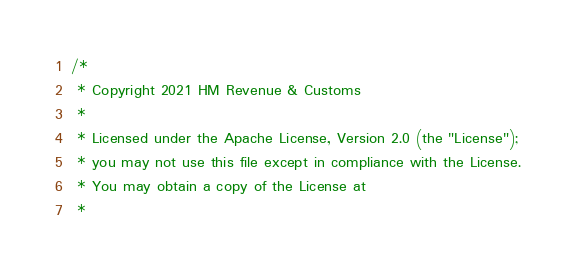Convert code to text. <code><loc_0><loc_0><loc_500><loc_500><_Scala_>/*
 * Copyright 2021 HM Revenue & Customs
 *
 * Licensed under the Apache License, Version 2.0 (the "License");
 * you may not use this file except in compliance with the License.
 * You may obtain a copy of the License at
 *</code> 